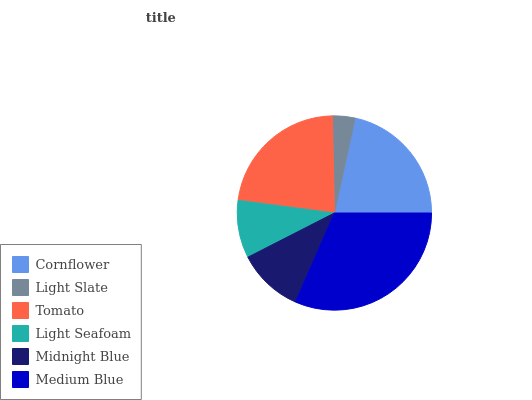Is Light Slate the minimum?
Answer yes or no. Yes. Is Medium Blue the maximum?
Answer yes or no. Yes. Is Tomato the minimum?
Answer yes or no. No. Is Tomato the maximum?
Answer yes or no. No. Is Tomato greater than Light Slate?
Answer yes or no. Yes. Is Light Slate less than Tomato?
Answer yes or no. Yes. Is Light Slate greater than Tomato?
Answer yes or no. No. Is Tomato less than Light Slate?
Answer yes or no. No. Is Cornflower the high median?
Answer yes or no. Yes. Is Midnight Blue the low median?
Answer yes or no. Yes. Is Tomato the high median?
Answer yes or no. No. Is Tomato the low median?
Answer yes or no. No. 